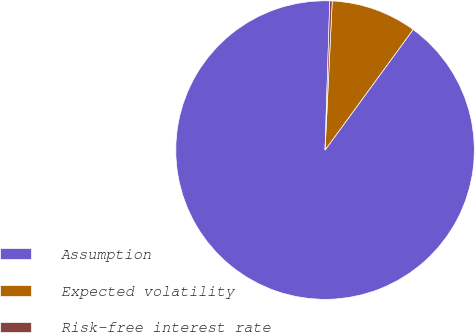Convert chart to OTSL. <chart><loc_0><loc_0><loc_500><loc_500><pie_chart><fcel>Assumption<fcel>Expected volatility<fcel>Risk-free interest rate<nl><fcel>90.46%<fcel>9.28%<fcel>0.26%<nl></chart> 